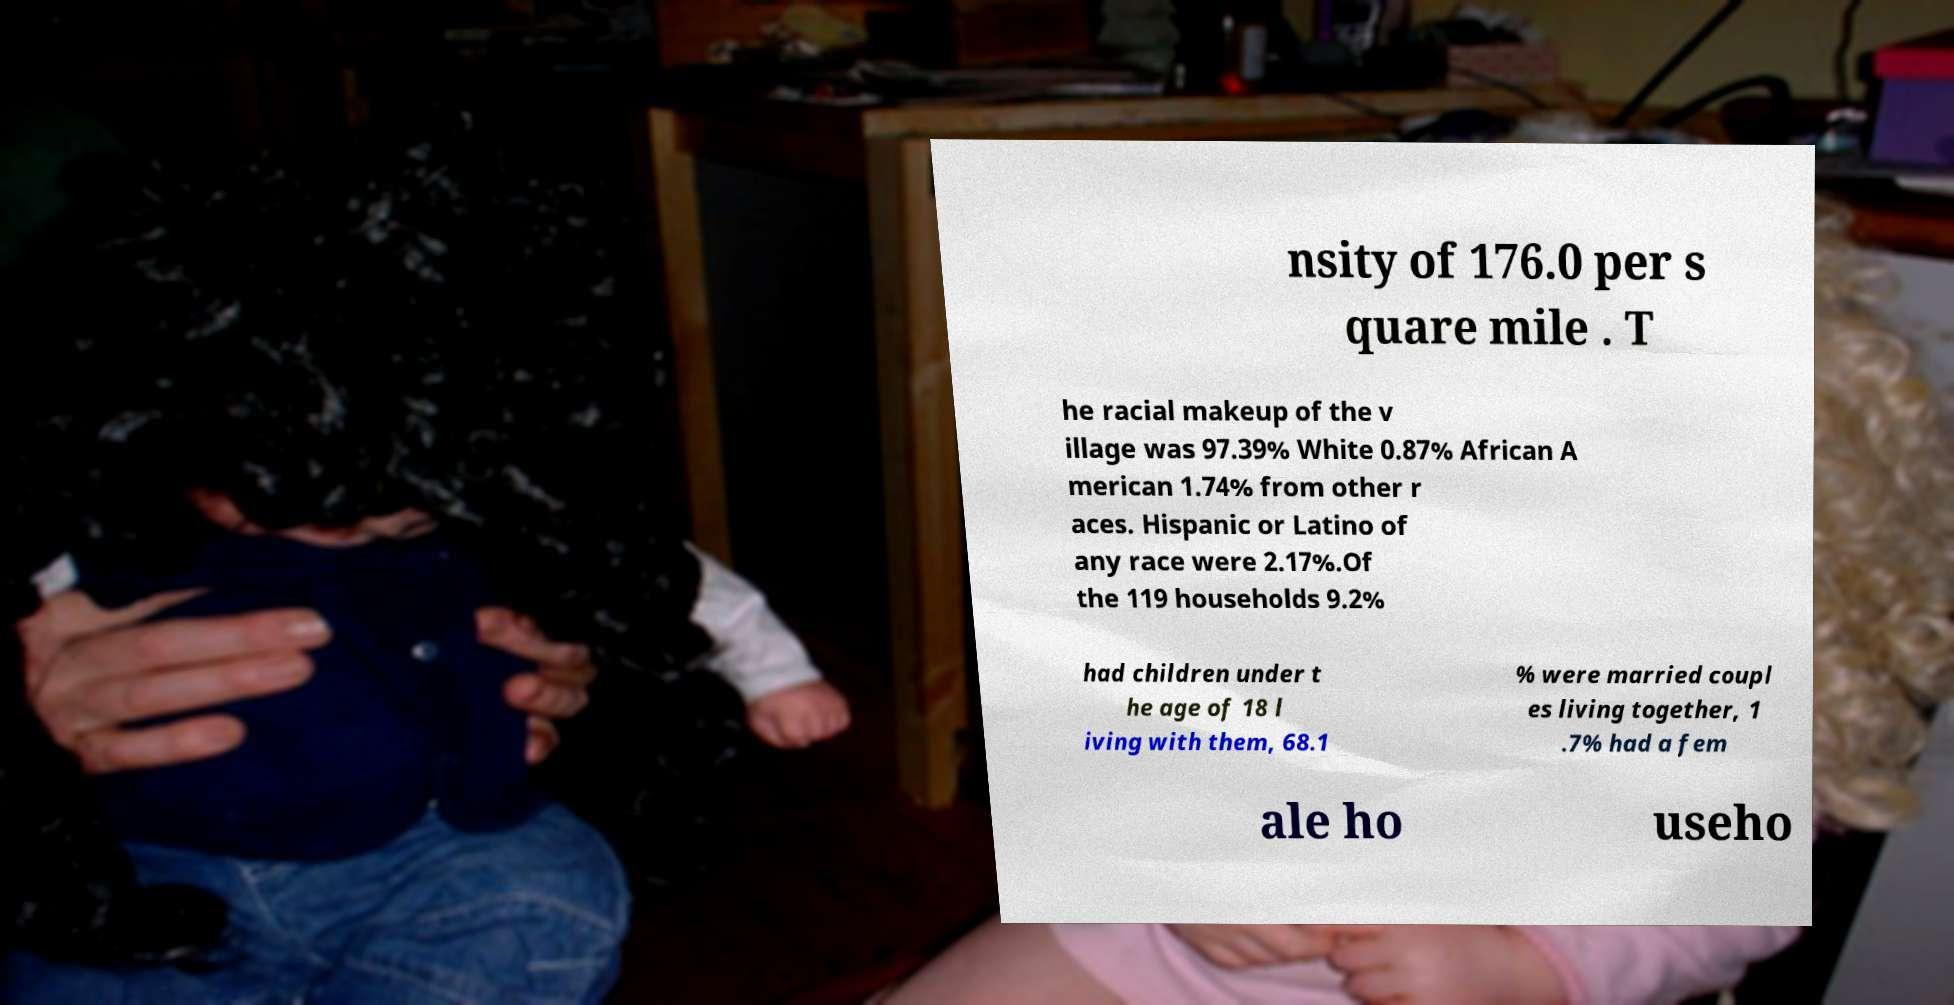What messages or text are displayed in this image? I need them in a readable, typed format. nsity of 176.0 per s quare mile . T he racial makeup of the v illage was 97.39% White 0.87% African A merican 1.74% from other r aces. Hispanic or Latino of any race were 2.17%.Of the 119 households 9.2% had children under t he age of 18 l iving with them, 68.1 % were married coupl es living together, 1 .7% had a fem ale ho useho 